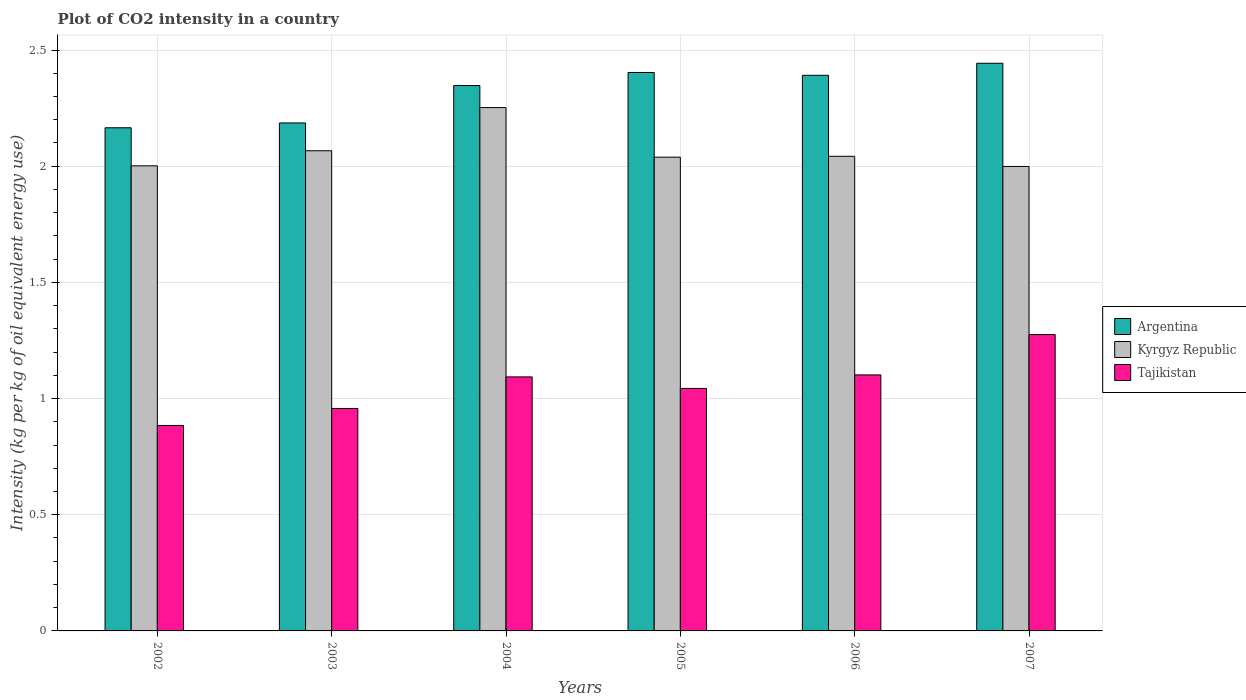How many bars are there on the 2nd tick from the right?
Offer a terse response. 3. What is the CO2 intensity in in Tajikistan in 2006?
Your answer should be compact. 1.1. Across all years, what is the maximum CO2 intensity in in Tajikistan?
Give a very brief answer. 1.28. Across all years, what is the minimum CO2 intensity in in Kyrgyz Republic?
Keep it short and to the point. 2. In which year was the CO2 intensity in in Kyrgyz Republic maximum?
Offer a very short reply. 2004. What is the total CO2 intensity in in Tajikistan in the graph?
Offer a terse response. 6.36. What is the difference between the CO2 intensity in in Argentina in 2002 and that in 2005?
Make the answer very short. -0.24. What is the difference between the CO2 intensity in in Kyrgyz Republic in 2006 and the CO2 intensity in in Argentina in 2002?
Provide a short and direct response. -0.12. What is the average CO2 intensity in in Kyrgyz Republic per year?
Your answer should be very brief. 2.07. In the year 2006, what is the difference between the CO2 intensity in in Kyrgyz Republic and CO2 intensity in in Argentina?
Keep it short and to the point. -0.35. In how many years, is the CO2 intensity in in Tajikistan greater than 1.4 kg?
Offer a terse response. 0. What is the ratio of the CO2 intensity in in Kyrgyz Republic in 2003 to that in 2004?
Keep it short and to the point. 0.92. What is the difference between the highest and the second highest CO2 intensity in in Tajikistan?
Keep it short and to the point. 0.17. What is the difference between the highest and the lowest CO2 intensity in in Kyrgyz Republic?
Your answer should be compact. 0.25. What does the 3rd bar from the left in 2007 represents?
Keep it short and to the point. Tajikistan. Is it the case that in every year, the sum of the CO2 intensity in in Kyrgyz Republic and CO2 intensity in in Tajikistan is greater than the CO2 intensity in in Argentina?
Your answer should be compact. Yes. How many bars are there?
Keep it short and to the point. 18. Are all the bars in the graph horizontal?
Give a very brief answer. No. How many years are there in the graph?
Provide a succinct answer. 6. Are the values on the major ticks of Y-axis written in scientific E-notation?
Offer a very short reply. No. Does the graph contain grids?
Offer a very short reply. Yes. How are the legend labels stacked?
Provide a succinct answer. Vertical. What is the title of the graph?
Provide a short and direct response. Plot of CO2 intensity in a country. What is the label or title of the Y-axis?
Keep it short and to the point. Intensity (kg per kg of oil equivalent energy use). What is the Intensity (kg per kg of oil equivalent energy use) in Argentina in 2002?
Your answer should be compact. 2.17. What is the Intensity (kg per kg of oil equivalent energy use) in Kyrgyz Republic in 2002?
Offer a very short reply. 2. What is the Intensity (kg per kg of oil equivalent energy use) in Tajikistan in 2002?
Provide a short and direct response. 0.88. What is the Intensity (kg per kg of oil equivalent energy use) in Argentina in 2003?
Your answer should be very brief. 2.19. What is the Intensity (kg per kg of oil equivalent energy use) of Kyrgyz Republic in 2003?
Your answer should be very brief. 2.07. What is the Intensity (kg per kg of oil equivalent energy use) of Tajikistan in 2003?
Provide a short and direct response. 0.96. What is the Intensity (kg per kg of oil equivalent energy use) of Argentina in 2004?
Provide a succinct answer. 2.35. What is the Intensity (kg per kg of oil equivalent energy use) of Kyrgyz Republic in 2004?
Give a very brief answer. 2.25. What is the Intensity (kg per kg of oil equivalent energy use) in Tajikistan in 2004?
Keep it short and to the point. 1.09. What is the Intensity (kg per kg of oil equivalent energy use) in Argentina in 2005?
Give a very brief answer. 2.4. What is the Intensity (kg per kg of oil equivalent energy use) in Kyrgyz Republic in 2005?
Keep it short and to the point. 2.04. What is the Intensity (kg per kg of oil equivalent energy use) of Tajikistan in 2005?
Your answer should be compact. 1.04. What is the Intensity (kg per kg of oil equivalent energy use) in Argentina in 2006?
Offer a very short reply. 2.39. What is the Intensity (kg per kg of oil equivalent energy use) of Kyrgyz Republic in 2006?
Offer a terse response. 2.04. What is the Intensity (kg per kg of oil equivalent energy use) in Tajikistan in 2006?
Offer a very short reply. 1.1. What is the Intensity (kg per kg of oil equivalent energy use) in Argentina in 2007?
Your answer should be very brief. 2.44. What is the Intensity (kg per kg of oil equivalent energy use) in Kyrgyz Republic in 2007?
Your answer should be compact. 2. What is the Intensity (kg per kg of oil equivalent energy use) in Tajikistan in 2007?
Your answer should be very brief. 1.28. Across all years, what is the maximum Intensity (kg per kg of oil equivalent energy use) of Argentina?
Your response must be concise. 2.44. Across all years, what is the maximum Intensity (kg per kg of oil equivalent energy use) in Kyrgyz Republic?
Your answer should be very brief. 2.25. Across all years, what is the maximum Intensity (kg per kg of oil equivalent energy use) of Tajikistan?
Your answer should be very brief. 1.28. Across all years, what is the minimum Intensity (kg per kg of oil equivalent energy use) of Argentina?
Make the answer very short. 2.17. Across all years, what is the minimum Intensity (kg per kg of oil equivalent energy use) in Kyrgyz Republic?
Your answer should be very brief. 2. Across all years, what is the minimum Intensity (kg per kg of oil equivalent energy use) of Tajikistan?
Your response must be concise. 0.88. What is the total Intensity (kg per kg of oil equivalent energy use) of Argentina in the graph?
Offer a very short reply. 13.94. What is the total Intensity (kg per kg of oil equivalent energy use) of Kyrgyz Republic in the graph?
Keep it short and to the point. 12.4. What is the total Intensity (kg per kg of oil equivalent energy use) of Tajikistan in the graph?
Make the answer very short. 6.36. What is the difference between the Intensity (kg per kg of oil equivalent energy use) in Argentina in 2002 and that in 2003?
Make the answer very short. -0.02. What is the difference between the Intensity (kg per kg of oil equivalent energy use) in Kyrgyz Republic in 2002 and that in 2003?
Your response must be concise. -0.06. What is the difference between the Intensity (kg per kg of oil equivalent energy use) in Tajikistan in 2002 and that in 2003?
Ensure brevity in your answer.  -0.07. What is the difference between the Intensity (kg per kg of oil equivalent energy use) of Argentina in 2002 and that in 2004?
Keep it short and to the point. -0.18. What is the difference between the Intensity (kg per kg of oil equivalent energy use) in Kyrgyz Republic in 2002 and that in 2004?
Keep it short and to the point. -0.25. What is the difference between the Intensity (kg per kg of oil equivalent energy use) in Tajikistan in 2002 and that in 2004?
Offer a terse response. -0.21. What is the difference between the Intensity (kg per kg of oil equivalent energy use) in Argentina in 2002 and that in 2005?
Provide a succinct answer. -0.24. What is the difference between the Intensity (kg per kg of oil equivalent energy use) in Kyrgyz Republic in 2002 and that in 2005?
Give a very brief answer. -0.04. What is the difference between the Intensity (kg per kg of oil equivalent energy use) of Tajikistan in 2002 and that in 2005?
Offer a terse response. -0.16. What is the difference between the Intensity (kg per kg of oil equivalent energy use) of Argentina in 2002 and that in 2006?
Offer a very short reply. -0.23. What is the difference between the Intensity (kg per kg of oil equivalent energy use) of Kyrgyz Republic in 2002 and that in 2006?
Offer a very short reply. -0.04. What is the difference between the Intensity (kg per kg of oil equivalent energy use) in Tajikistan in 2002 and that in 2006?
Give a very brief answer. -0.22. What is the difference between the Intensity (kg per kg of oil equivalent energy use) of Argentina in 2002 and that in 2007?
Keep it short and to the point. -0.28. What is the difference between the Intensity (kg per kg of oil equivalent energy use) of Kyrgyz Republic in 2002 and that in 2007?
Offer a terse response. 0. What is the difference between the Intensity (kg per kg of oil equivalent energy use) in Tajikistan in 2002 and that in 2007?
Give a very brief answer. -0.39. What is the difference between the Intensity (kg per kg of oil equivalent energy use) of Argentina in 2003 and that in 2004?
Give a very brief answer. -0.16. What is the difference between the Intensity (kg per kg of oil equivalent energy use) of Kyrgyz Republic in 2003 and that in 2004?
Make the answer very short. -0.19. What is the difference between the Intensity (kg per kg of oil equivalent energy use) in Tajikistan in 2003 and that in 2004?
Provide a short and direct response. -0.14. What is the difference between the Intensity (kg per kg of oil equivalent energy use) in Argentina in 2003 and that in 2005?
Your answer should be very brief. -0.22. What is the difference between the Intensity (kg per kg of oil equivalent energy use) of Kyrgyz Republic in 2003 and that in 2005?
Provide a succinct answer. 0.03. What is the difference between the Intensity (kg per kg of oil equivalent energy use) in Tajikistan in 2003 and that in 2005?
Keep it short and to the point. -0.09. What is the difference between the Intensity (kg per kg of oil equivalent energy use) of Argentina in 2003 and that in 2006?
Provide a succinct answer. -0.2. What is the difference between the Intensity (kg per kg of oil equivalent energy use) in Kyrgyz Republic in 2003 and that in 2006?
Ensure brevity in your answer.  0.02. What is the difference between the Intensity (kg per kg of oil equivalent energy use) of Tajikistan in 2003 and that in 2006?
Your response must be concise. -0.14. What is the difference between the Intensity (kg per kg of oil equivalent energy use) of Argentina in 2003 and that in 2007?
Provide a short and direct response. -0.26. What is the difference between the Intensity (kg per kg of oil equivalent energy use) of Kyrgyz Republic in 2003 and that in 2007?
Provide a succinct answer. 0.07. What is the difference between the Intensity (kg per kg of oil equivalent energy use) of Tajikistan in 2003 and that in 2007?
Keep it short and to the point. -0.32. What is the difference between the Intensity (kg per kg of oil equivalent energy use) of Argentina in 2004 and that in 2005?
Provide a succinct answer. -0.06. What is the difference between the Intensity (kg per kg of oil equivalent energy use) of Kyrgyz Republic in 2004 and that in 2005?
Provide a succinct answer. 0.21. What is the difference between the Intensity (kg per kg of oil equivalent energy use) of Tajikistan in 2004 and that in 2005?
Ensure brevity in your answer.  0.05. What is the difference between the Intensity (kg per kg of oil equivalent energy use) in Argentina in 2004 and that in 2006?
Your answer should be compact. -0.04. What is the difference between the Intensity (kg per kg of oil equivalent energy use) in Kyrgyz Republic in 2004 and that in 2006?
Your response must be concise. 0.21. What is the difference between the Intensity (kg per kg of oil equivalent energy use) in Tajikistan in 2004 and that in 2006?
Ensure brevity in your answer.  -0.01. What is the difference between the Intensity (kg per kg of oil equivalent energy use) of Argentina in 2004 and that in 2007?
Keep it short and to the point. -0.1. What is the difference between the Intensity (kg per kg of oil equivalent energy use) in Kyrgyz Republic in 2004 and that in 2007?
Ensure brevity in your answer.  0.25. What is the difference between the Intensity (kg per kg of oil equivalent energy use) of Tajikistan in 2004 and that in 2007?
Offer a very short reply. -0.18. What is the difference between the Intensity (kg per kg of oil equivalent energy use) of Argentina in 2005 and that in 2006?
Make the answer very short. 0.01. What is the difference between the Intensity (kg per kg of oil equivalent energy use) in Kyrgyz Republic in 2005 and that in 2006?
Your response must be concise. -0. What is the difference between the Intensity (kg per kg of oil equivalent energy use) in Tajikistan in 2005 and that in 2006?
Offer a terse response. -0.06. What is the difference between the Intensity (kg per kg of oil equivalent energy use) in Argentina in 2005 and that in 2007?
Ensure brevity in your answer.  -0.04. What is the difference between the Intensity (kg per kg of oil equivalent energy use) of Kyrgyz Republic in 2005 and that in 2007?
Your answer should be very brief. 0.04. What is the difference between the Intensity (kg per kg of oil equivalent energy use) in Tajikistan in 2005 and that in 2007?
Ensure brevity in your answer.  -0.23. What is the difference between the Intensity (kg per kg of oil equivalent energy use) of Argentina in 2006 and that in 2007?
Provide a short and direct response. -0.05. What is the difference between the Intensity (kg per kg of oil equivalent energy use) in Kyrgyz Republic in 2006 and that in 2007?
Ensure brevity in your answer.  0.04. What is the difference between the Intensity (kg per kg of oil equivalent energy use) of Tajikistan in 2006 and that in 2007?
Provide a short and direct response. -0.17. What is the difference between the Intensity (kg per kg of oil equivalent energy use) of Argentina in 2002 and the Intensity (kg per kg of oil equivalent energy use) of Kyrgyz Republic in 2003?
Keep it short and to the point. 0.1. What is the difference between the Intensity (kg per kg of oil equivalent energy use) of Argentina in 2002 and the Intensity (kg per kg of oil equivalent energy use) of Tajikistan in 2003?
Make the answer very short. 1.21. What is the difference between the Intensity (kg per kg of oil equivalent energy use) in Kyrgyz Republic in 2002 and the Intensity (kg per kg of oil equivalent energy use) in Tajikistan in 2003?
Your answer should be compact. 1.04. What is the difference between the Intensity (kg per kg of oil equivalent energy use) in Argentina in 2002 and the Intensity (kg per kg of oil equivalent energy use) in Kyrgyz Republic in 2004?
Provide a succinct answer. -0.09. What is the difference between the Intensity (kg per kg of oil equivalent energy use) in Argentina in 2002 and the Intensity (kg per kg of oil equivalent energy use) in Tajikistan in 2004?
Give a very brief answer. 1.07. What is the difference between the Intensity (kg per kg of oil equivalent energy use) in Kyrgyz Republic in 2002 and the Intensity (kg per kg of oil equivalent energy use) in Tajikistan in 2004?
Keep it short and to the point. 0.91. What is the difference between the Intensity (kg per kg of oil equivalent energy use) in Argentina in 2002 and the Intensity (kg per kg of oil equivalent energy use) in Kyrgyz Republic in 2005?
Your answer should be very brief. 0.13. What is the difference between the Intensity (kg per kg of oil equivalent energy use) in Argentina in 2002 and the Intensity (kg per kg of oil equivalent energy use) in Tajikistan in 2005?
Offer a terse response. 1.12. What is the difference between the Intensity (kg per kg of oil equivalent energy use) in Kyrgyz Republic in 2002 and the Intensity (kg per kg of oil equivalent energy use) in Tajikistan in 2005?
Provide a short and direct response. 0.96. What is the difference between the Intensity (kg per kg of oil equivalent energy use) in Argentina in 2002 and the Intensity (kg per kg of oil equivalent energy use) in Kyrgyz Republic in 2006?
Make the answer very short. 0.12. What is the difference between the Intensity (kg per kg of oil equivalent energy use) of Argentina in 2002 and the Intensity (kg per kg of oil equivalent energy use) of Tajikistan in 2006?
Your answer should be compact. 1.06. What is the difference between the Intensity (kg per kg of oil equivalent energy use) of Kyrgyz Republic in 2002 and the Intensity (kg per kg of oil equivalent energy use) of Tajikistan in 2006?
Provide a succinct answer. 0.9. What is the difference between the Intensity (kg per kg of oil equivalent energy use) in Argentina in 2002 and the Intensity (kg per kg of oil equivalent energy use) in Kyrgyz Republic in 2007?
Provide a succinct answer. 0.17. What is the difference between the Intensity (kg per kg of oil equivalent energy use) in Argentina in 2002 and the Intensity (kg per kg of oil equivalent energy use) in Tajikistan in 2007?
Offer a very short reply. 0.89. What is the difference between the Intensity (kg per kg of oil equivalent energy use) in Kyrgyz Republic in 2002 and the Intensity (kg per kg of oil equivalent energy use) in Tajikistan in 2007?
Offer a very short reply. 0.73. What is the difference between the Intensity (kg per kg of oil equivalent energy use) of Argentina in 2003 and the Intensity (kg per kg of oil equivalent energy use) of Kyrgyz Republic in 2004?
Offer a terse response. -0.07. What is the difference between the Intensity (kg per kg of oil equivalent energy use) in Argentina in 2003 and the Intensity (kg per kg of oil equivalent energy use) in Tajikistan in 2004?
Keep it short and to the point. 1.09. What is the difference between the Intensity (kg per kg of oil equivalent energy use) of Kyrgyz Republic in 2003 and the Intensity (kg per kg of oil equivalent energy use) of Tajikistan in 2004?
Your answer should be compact. 0.97. What is the difference between the Intensity (kg per kg of oil equivalent energy use) of Argentina in 2003 and the Intensity (kg per kg of oil equivalent energy use) of Kyrgyz Republic in 2005?
Keep it short and to the point. 0.15. What is the difference between the Intensity (kg per kg of oil equivalent energy use) in Argentina in 2003 and the Intensity (kg per kg of oil equivalent energy use) in Tajikistan in 2005?
Ensure brevity in your answer.  1.14. What is the difference between the Intensity (kg per kg of oil equivalent energy use) of Kyrgyz Republic in 2003 and the Intensity (kg per kg of oil equivalent energy use) of Tajikistan in 2005?
Provide a short and direct response. 1.02. What is the difference between the Intensity (kg per kg of oil equivalent energy use) of Argentina in 2003 and the Intensity (kg per kg of oil equivalent energy use) of Kyrgyz Republic in 2006?
Provide a succinct answer. 0.14. What is the difference between the Intensity (kg per kg of oil equivalent energy use) in Argentina in 2003 and the Intensity (kg per kg of oil equivalent energy use) in Tajikistan in 2006?
Keep it short and to the point. 1.08. What is the difference between the Intensity (kg per kg of oil equivalent energy use) of Kyrgyz Republic in 2003 and the Intensity (kg per kg of oil equivalent energy use) of Tajikistan in 2006?
Your answer should be very brief. 0.96. What is the difference between the Intensity (kg per kg of oil equivalent energy use) in Argentina in 2003 and the Intensity (kg per kg of oil equivalent energy use) in Kyrgyz Republic in 2007?
Your answer should be compact. 0.19. What is the difference between the Intensity (kg per kg of oil equivalent energy use) in Argentina in 2003 and the Intensity (kg per kg of oil equivalent energy use) in Tajikistan in 2007?
Offer a terse response. 0.91. What is the difference between the Intensity (kg per kg of oil equivalent energy use) of Kyrgyz Republic in 2003 and the Intensity (kg per kg of oil equivalent energy use) of Tajikistan in 2007?
Ensure brevity in your answer.  0.79. What is the difference between the Intensity (kg per kg of oil equivalent energy use) of Argentina in 2004 and the Intensity (kg per kg of oil equivalent energy use) of Kyrgyz Republic in 2005?
Make the answer very short. 0.31. What is the difference between the Intensity (kg per kg of oil equivalent energy use) of Argentina in 2004 and the Intensity (kg per kg of oil equivalent energy use) of Tajikistan in 2005?
Keep it short and to the point. 1.3. What is the difference between the Intensity (kg per kg of oil equivalent energy use) of Kyrgyz Republic in 2004 and the Intensity (kg per kg of oil equivalent energy use) of Tajikistan in 2005?
Give a very brief answer. 1.21. What is the difference between the Intensity (kg per kg of oil equivalent energy use) of Argentina in 2004 and the Intensity (kg per kg of oil equivalent energy use) of Kyrgyz Republic in 2006?
Your response must be concise. 0.3. What is the difference between the Intensity (kg per kg of oil equivalent energy use) of Argentina in 2004 and the Intensity (kg per kg of oil equivalent energy use) of Tajikistan in 2006?
Keep it short and to the point. 1.25. What is the difference between the Intensity (kg per kg of oil equivalent energy use) of Kyrgyz Republic in 2004 and the Intensity (kg per kg of oil equivalent energy use) of Tajikistan in 2006?
Offer a very short reply. 1.15. What is the difference between the Intensity (kg per kg of oil equivalent energy use) in Argentina in 2004 and the Intensity (kg per kg of oil equivalent energy use) in Kyrgyz Republic in 2007?
Your response must be concise. 0.35. What is the difference between the Intensity (kg per kg of oil equivalent energy use) in Argentina in 2004 and the Intensity (kg per kg of oil equivalent energy use) in Tajikistan in 2007?
Provide a short and direct response. 1.07. What is the difference between the Intensity (kg per kg of oil equivalent energy use) in Kyrgyz Republic in 2004 and the Intensity (kg per kg of oil equivalent energy use) in Tajikistan in 2007?
Provide a succinct answer. 0.98. What is the difference between the Intensity (kg per kg of oil equivalent energy use) of Argentina in 2005 and the Intensity (kg per kg of oil equivalent energy use) of Kyrgyz Republic in 2006?
Offer a terse response. 0.36. What is the difference between the Intensity (kg per kg of oil equivalent energy use) in Argentina in 2005 and the Intensity (kg per kg of oil equivalent energy use) in Tajikistan in 2006?
Ensure brevity in your answer.  1.3. What is the difference between the Intensity (kg per kg of oil equivalent energy use) in Kyrgyz Republic in 2005 and the Intensity (kg per kg of oil equivalent energy use) in Tajikistan in 2006?
Provide a short and direct response. 0.94. What is the difference between the Intensity (kg per kg of oil equivalent energy use) in Argentina in 2005 and the Intensity (kg per kg of oil equivalent energy use) in Kyrgyz Republic in 2007?
Provide a succinct answer. 0.4. What is the difference between the Intensity (kg per kg of oil equivalent energy use) in Argentina in 2005 and the Intensity (kg per kg of oil equivalent energy use) in Tajikistan in 2007?
Keep it short and to the point. 1.13. What is the difference between the Intensity (kg per kg of oil equivalent energy use) in Kyrgyz Republic in 2005 and the Intensity (kg per kg of oil equivalent energy use) in Tajikistan in 2007?
Your response must be concise. 0.76. What is the difference between the Intensity (kg per kg of oil equivalent energy use) of Argentina in 2006 and the Intensity (kg per kg of oil equivalent energy use) of Kyrgyz Republic in 2007?
Give a very brief answer. 0.39. What is the difference between the Intensity (kg per kg of oil equivalent energy use) of Argentina in 2006 and the Intensity (kg per kg of oil equivalent energy use) of Tajikistan in 2007?
Give a very brief answer. 1.12. What is the difference between the Intensity (kg per kg of oil equivalent energy use) of Kyrgyz Republic in 2006 and the Intensity (kg per kg of oil equivalent energy use) of Tajikistan in 2007?
Keep it short and to the point. 0.77. What is the average Intensity (kg per kg of oil equivalent energy use) of Argentina per year?
Your answer should be very brief. 2.32. What is the average Intensity (kg per kg of oil equivalent energy use) in Kyrgyz Republic per year?
Your answer should be compact. 2.07. What is the average Intensity (kg per kg of oil equivalent energy use) of Tajikistan per year?
Make the answer very short. 1.06. In the year 2002, what is the difference between the Intensity (kg per kg of oil equivalent energy use) in Argentina and Intensity (kg per kg of oil equivalent energy use) in Kyrgyz Republic?
Your answer should be very brief. 0.16. In the year 2002, what is the difference between the Intensity (kg per kg of oil equivalent energy use) of Argentina and Intensity (kg per kg of oil equivalent energy use) of Tajikistan?
Make the answer very short. 1.28. In the year 2002, what is the difference between the Intensity (kg per kg of oil equivalent energy use) of Kyrgyz Republic and Intensity (kg per kg of oil equivalent energy use) of Tajikistan?
Your answer should be very brief. 1.12. In the year 2003, what is the difference between the Intensity (kg per kg of oil equivalent energy use) of Argentina and Intensity (kg per kg of oil equivalent energy use) of Kyrgyz Republic?
Your answer should be compact. 0.12. In the year 2003, what is the difference between the Intensity (kg per kg of oil equivalent energy use) in Argentina and Intensity (kg per kg of oil equivalent energy use) in Tajikistan?
Your answer should be very brief. 1.23. In the year 2003, what is the difference between the Intensity (kg per kg of oil equivalent energy use) in Kyrgyz Republic and Intensity (kg per kg of oil equivalent energy use) in Tajikistan?
Keep it short and to the point. 1.11. In the year 2004, what is the difference between the Intensity (kg per kg of oil equivalent energy use) in Argentina and Intensity (kg per kg of oil equivalent energy use) in Kyrgyz Republic?
Offer a terse response. 0.09. In the year 2004, what is the difference between the Intensity (kg per kg of oil equivalent energy use) in Argentina and Intensity (kg per kg of oil equivalent energy use) in Tajikistan?
Ensure brevity in your answer.  1.25. In the year 2004, what is the difference between the Intensity (kg per kg of oil equivalent energy use) in Kyrgyz Republic and Intensity (kg per kg of oil equivalent energy use) in Tajikistan?
Offer a very short reply. 1.16. In the year 2005, what is the difference between the Intensity (kg per kg of oil equivalent energy use) in Argentina and Intensity (kg per kg of oil equivalent energy use) in Kyrgyz Republic?
Provide a short and direct response. 0.36. In the year 2005, what is the difference between the Intensity (kg per kg of oil equivalent energy use) in Argentina and Intensity (kg per kg of oil equivalent energy use) in Tajikistan?
Keep it short and to the point. 1.36. In the year 2006, what is the difference between the Intensity (kg per kg of oil equivalent energy use) of Argentina and Intensity (kg per kg of oil equivalent energy use) of Kyrgyz Republic?
Give a very brief answer. 0.35. In the year 2006, what is the difference between the Intensity (kg per kg of oil equivalent energy use) of Argentina and Intensity (kg per kg of oil equivalent energy use) of Tajikistan?
Keep it short and to the point. 1.29. In the year 2006, what is the difference between the Intensity (kg per kg of oil equivalent energy use) of Kyrgyz Republic and Intensity (kg per kg of oil equivalent energy use) of Tajikistan?
Offer a terse response. 0.94. In the year 2007, what is the difference between the Intensity (kg per kg of oil equivalent energy use) of Argentina and Intensity (kg per kg of oil equivalent energy use) of Kyrgyz Republic?
Your answer should be very brief. 0.44. In the year 2007, what is the difference between the Intensity (kg per kg of oil equivalent energy use) in Argentina and Intensity (kg per kg of oil equivalent energy use) in Tajikistan?
Your answer should be very brief. 1.17. In the year 2007, what is the difference between the Intensity (kg per kg of oil equivalent energy use) of Kyrgyz Republic and Intensity (kg per kg of oil equivalent energy use) of Tajikistan?
Offer a terse response. 0.72. What is the ratio of the Intensity (kg per kg of oil equivalent energy use) in Argentina in 2002 to that in 2003?
Ensure brevity in your answer.  0.99. What is the ratio of the Intensity (kg per kg of oil equivalent energy use) of Kyrgyz Republic in 2002 to that in 2003?
Your response must be concise. 0.97. What is the ratio of the Intensity (kg per kg of oil equivalent energy use) of Tajikistan in 2002 to that in 2003?
Provide a short and direct response. 0.92. What is the ratio of the Intensity (kg per kg of oil equivalent energy use) in Argentina in 2002 to that in 2004?
Provide a short and direct response. 0.92. What is the ratio of the Intensity (kg per kg of oil equivalent energy use) of Kyrgyz Republic in 2002 to that in 2004?
Ensure brevity in your answer.  0.89. What is the ratio of the Intensity (kg per kg of oil equivalent energy use) in Tajikistan in 2002 to that in 2004?
Your answer should be compact. 0.81. What is the ratio of the Intensity (kg per kg of oil equivalent energy use) in Argentina in 2002 to that in 2005?
Your answer should be very brief. 0.9. What is the ratio of the Intensity (kg per kg of oil equivalent energy use) of Kyrgyz Republic in 2002 to that in 2005?
Provide a short and direct response. 0.98. What is the ratio of the Intensity (kg per kg of oil equivalent energy use) of Tajikistan in 2002 to that in 2005?
Your answer should be compact. 0.85. What is the ratio of the Intensity (kg per kg of oil equivalent energy use) of Argentina in 2002 to that in 2006?
Provide a succinct answer. 0.91. What is the ratio of the Intensity (kg per kg of oil equivalent energy use) in Kyrgyz Republic in 2002 to that in 2006?
Offer a terse response. 0.98. What is the ratio of the Intensity (kg per kg of oil equivalent energy use) of Tajikistan in 2002 to that in 2006?
Give a very brief answer. 0.8. What is the ratio of the Intensity (kg per kg of oil equivalent energy use) of Argentina in 2002 to that in 2007?
Keep it short and to the point. 0.89. What is the ratio of the Intensity (kg per kg of oil equivalent energy use) of Kyrgyz Republic in 2002 to that in 2007?
Your answer should be very brief. 1. What is the ratio of the Intensity (kg per kg of oil equivalent energy use) of Tajikistan in 2002 to that in 2007?
Keep it short and to the point. 0.69. What is the ratio of the Intensity (kg per kg of oil equivalent energy use) of Argentina in 2003 to that in 2004?
Your response must be concise. 0.93. What is the ratio of the Intensity (kg per kg of oil equivalent energy use) in Kyrgyz Republic in 2003 to that in 2004?
Ensure brevity in your answer.  0.92. What is the ratio of the Intensity (kg per kg of oil equivalent energy use) of Tajikistan in 2003 to that in 2004?
Offer a very short reply. 0.88. What is the ratio of the Intensity (kg per kg of oil equivalent energy use) of Argentina in 2003 to that in 2005?
Ensure brevity in your answer.  0.91. What is the ratio of the Intensity (kg per kg of oil equivalent energy use) in Kyrgyz Republic in 2003 to that in 2005?
Make the answer very short. 1.01. What is the ratio of the Intensity (kg per kg of oil equivalent energy use) in Tajikistan in 2003 to that in 2005?
Provide a short and direct response. 0.92. What is the ratio of the Intensity (kg per kg of oil equivalent energy use) in Argentina in 2003 to that in 2006?
Provide a short and direct response. 0.91. What is the ratio of the Intensity (kg per kg of oil equivalent energy use) of Kyrgyz Republic in 2003 to that in 2006?
Give a very brief answer. 1.01. What is the ratio of the Intensity (kg per kg of oil equivalent energy use) of Tajikistan in 2003 to that in 2006?
Keep it short and to the point. 0.87. What is the ratio of the Intensity (kg per kg of oil equivalent energy use) in Argentina in 2003 to that in 2007?
Make the answer very short. 0.89. What is the ratio of the Intensity (kg per kg of oil equivalent energy use) of Kyrgyz Republic in 2003 to that in 2007?
Your answer should be compact. 1.03. What is the ratio of the Intensity (kg per kg of oil equivalent energy use) of Tajikistan in 2003 to that in 2007?
Keep it short and to the point. 0.75. What is the ratio of the Intensity (kg per kg of oil equivalent energy use) of Argentina in 2004 to that in 2005?
Ensure brevity in your answer.  0.98. What is the ratio of the Intensity (kg per kg of oil equivalent energy use) of Kyrgyz Republic in 2004 to that in 2005?
Offer a very short reply. 1.1. What is the ratio of the Intensity (kg per kg of oil equivalent energy use) in Tajikistan in 2004 to that in 2005?
Give a very brief answer. 1.05. What is the ratio of the Intensity (kg per kg of oil equivalent energy use) in Argentina in 2004 to that in 2006?
Your answer should be very brief. 0.98. What is the ratio of the Intensity (kg per kg of oil equivalent energy use) in Kyrgyz Republic in 2004 to that in 2006?
Provide a succinct answer. 1.1. What is the ratio of the Intensity (kg per kg of oil equivalent energy use) in Argentina in 2004 to that in 2007?
Your answer should be compact. 0.96. What is the ratio of the Intensity (kg per kg of oil equivalent energy use) in Kyrgyz Republic in 2004 to that in 2007?
Offer a terse response. 1.13. What is the ratio of the Intensity (kg per kg of oil equivalent energy use) in Tajikistan in 2004 to that in 2007?
Keep it short and to the point. 0.86. What is the ratio of the Intensity (kg per kg of oil equivalent energy use) in Kyrgyz Republic in 2005 to that in 2006?
Your response must be concise. 1. What is the ratio of the Intensity (kg per kg of oil equivalent energy use) of Tajikistan in 2005 to that in 2006?
Your answer should be very brief. 0.95. What is the ratio of the Intensity (kg per kg of oil equivalent energy use) in Argentina in 2005 to that in 2007?
Your answer should be compact. 0.98. What is the ratio of the Intensity (kg per kg of oil equivalent energy use) in Kyrgyz Republic in 2005 to that in 2007?
Keep it short and to the point. 1.02. What is the ratio of the Intensity (kg per kg of oil equivalent energy use) in Tajikistan in 2005 to that in 2007?
Ensure brevity in your answer.  0.82. What is the ratio of the Intensity (kg per kg of oil equivalent energy use) of Argentina in 2006 to that in 2007?
Keep it short and to the point. 0.98. What is the ratio of the Intensity (kg per kg of oil equivalent energy use) in Kyrgyz Republic in 2006 to that in 2007?
Your answer should be very brief. 1.02. What is the ratio of the Intensity (kg per kg of oil equivalent energy use) in Tajikistan in 2006 to that in 2007?
Your answer should be very brief. 0.86. What is the difference between the highest and the second highest Intensity (kg per kg of oil equivalent energy use) in Argentina?
Give a very brief answer. 0.04. What is the difference between the highest and the second highest Intensity (kg per kg of oil equivalent energy use) in Kyrgyz Republic?
Keep it short and to the point. 0.19. What is the difference between the highest and the second highest Intensity (kg per kg of oil equivalent energy use) of Tajikistan?
Give a very brief answer. 0.17. What is the difference between the highest and the lowest Intensity (kg per kg of oil equivalent energy use) of Argentina?
Keep it short and to the point. 0.28. What is the difference between the highest and the lowest Intensity (kg per kg of oil equivalent energy use) in Kyrgyz Republic?
Provide a short and direct response. 0.25. What is the difference between the highest and the lowest Intensity (kg per kg of oil equivalent energy use) in Tajikistan?
Ensure brevity in your answer.  0.39. 